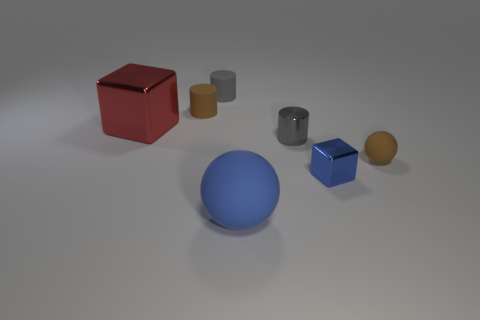Subtract all gray cylinders. How many were subtracted if there are1gray cylinders left? 1 Subtract all tiny gray cylinders. How many cylinders are left? 1 Subtract all cylinders. How many objects are left? 4 Subtract 1 spheres. How many spheres are left? 1 Add 3 green matte cylinders. How many objects exist? 10 Subtract all red blocks. How many blocks are left? 1 Subtract all purple spheres. How many gray cylinders are left? 2 Subtract all small purple metal blocks. Subtract all big matte objects. How many objects are left? 6 Add 3 tiny brown objects. How many tiny brown objects are left? 5 Add 6 small gray shiny cylinders. How many small gray shiny cylinders exist? 7 